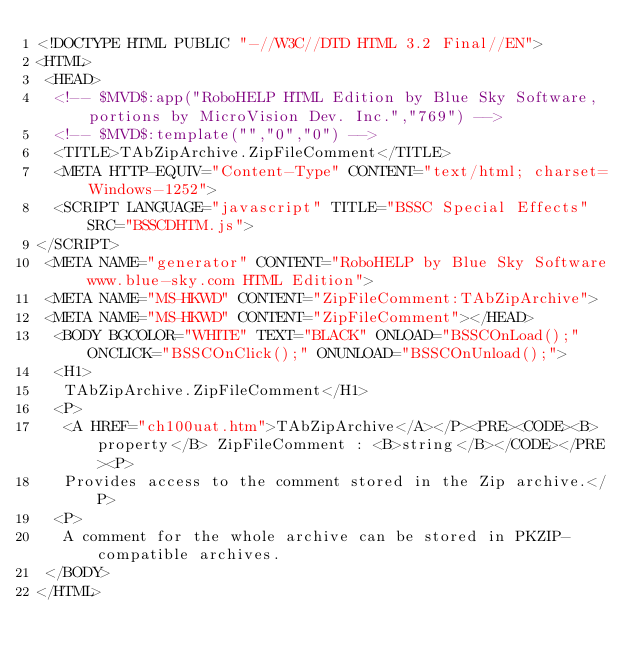Convert code to text. <code><loc_0><loc_0><loc_500><loc_500><_HTML_><!DOCTYPE HTML PUBLIC "-//W3C//DTD HTML 3.2 Final//EN">
<HTML>
 <HEAD>
  <!-- $MVD$:app("RoboHELP HTML Edition by Blue Sky Software, portions by MicroVision Dev. Inc.","769") -->
  <!-- $MVD$:template("","0","0") -->
  <TITLE>TAbZipArchive.ZipFileComment</TITLE>
  <META HTTP-EQUIV="Content-Type" CONTENT="text/html; charset=Windows-1252">
  <SCRIPT LANGUAGE="javascript" TITLE="BSSC Special Effects" SRC="BSSCDHTM.js">
</SCRIPT>
 <META NAME="generator" CONTENT="RoboHELP by Blue Sky Software www.blue-sky.com HTML Edition">
 <META NAME="MS-HKWD" CONTENT="ZipFileComment:TAbZipArchive">
 <META NAME="MS-HKWD" CONTENT="ZipFileComment"></HEAD>
  <BODY BGCOLOR="WHITE" TEXT="BLACK" ONLOAD="BSSCOnLoad();" ONCLICK="BSSCOnClick();" ONUNLOAD="BSSCOnUnload();">
  <H1>
   TAbZipArchive.ZipFileComment</H1>
  <P>
   <A HREF="ch100uat.htm">TAbZipArchive</A></P><PRE><CODE><B>property</B> ZipFileComment : <B>string</B></CODE></PRE><P>
   Provides access to the comment stored in the Zip archive.</P>
  <P>
   A comment for the whole archive can be stored in PKZIP-compatible archives.
 </BODY>
</HTML></code> 